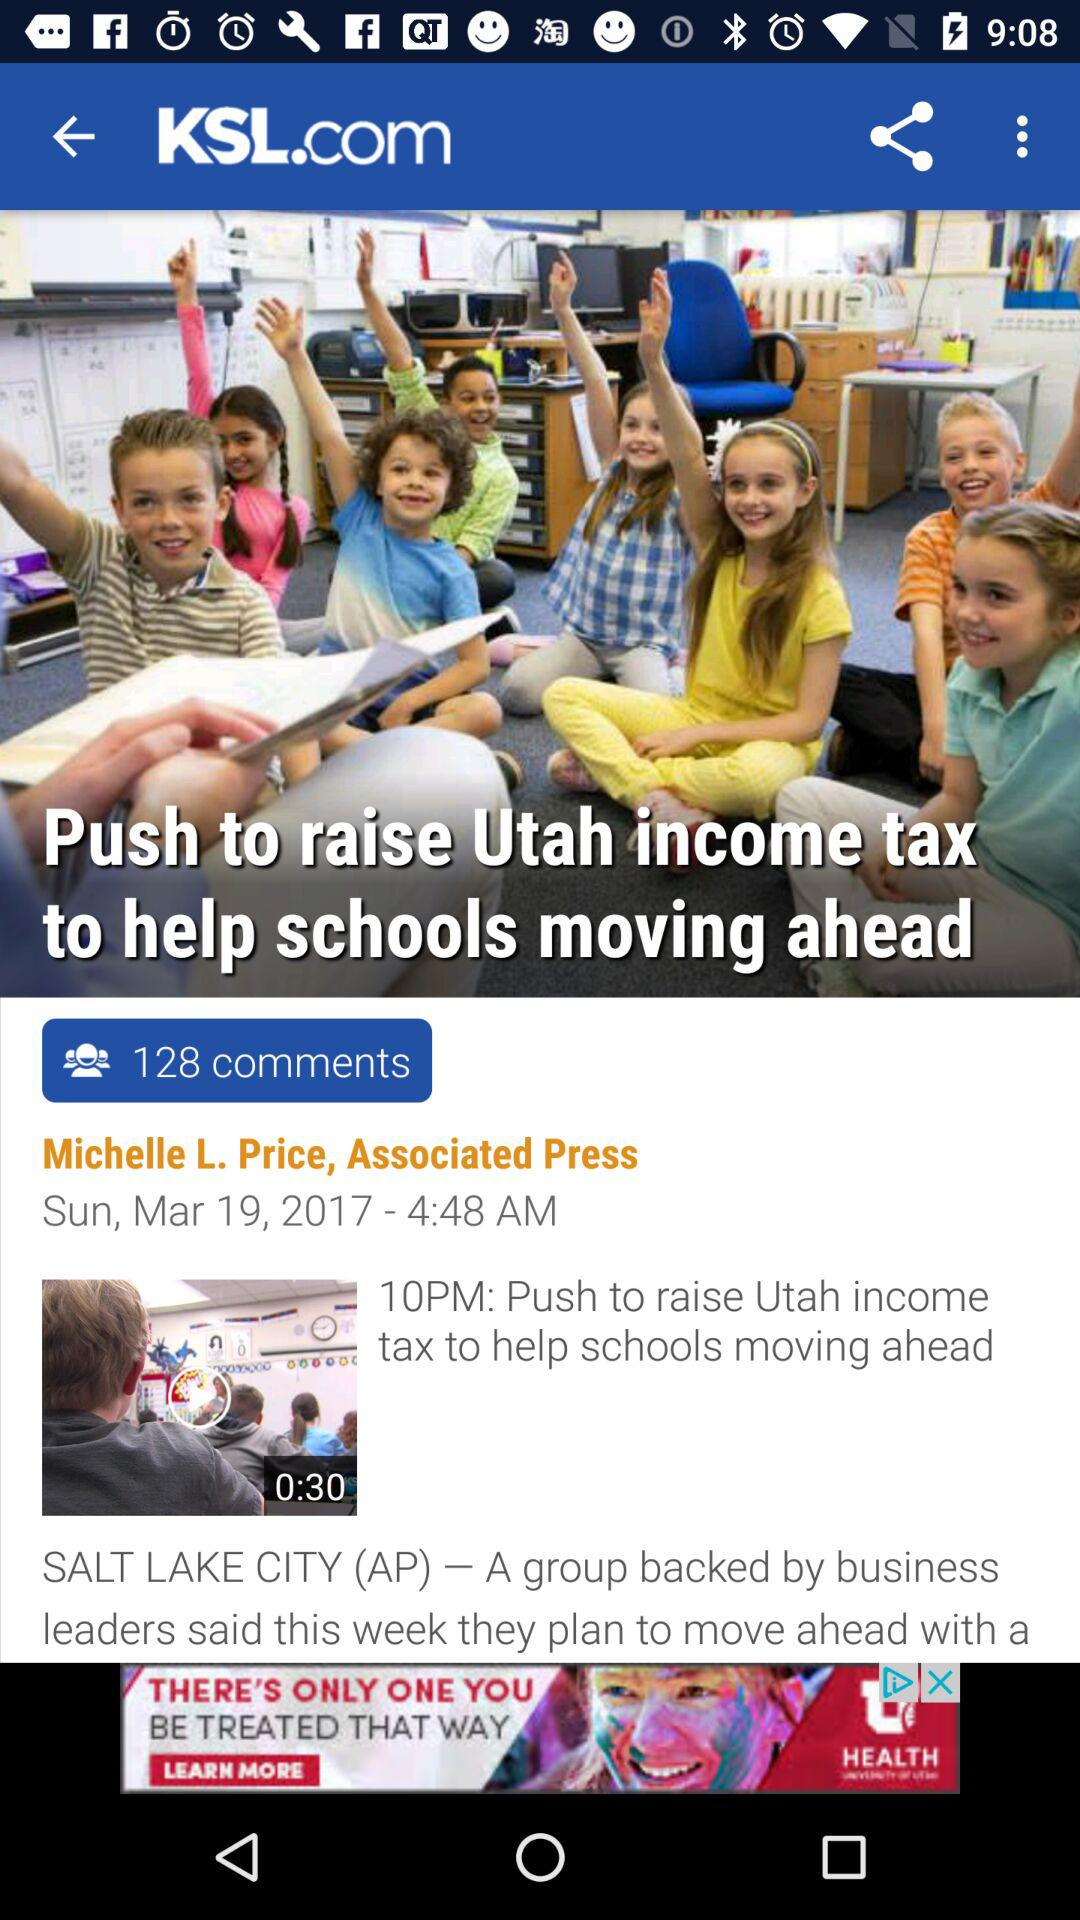How many comments are there on this article? There are 128 comments. 